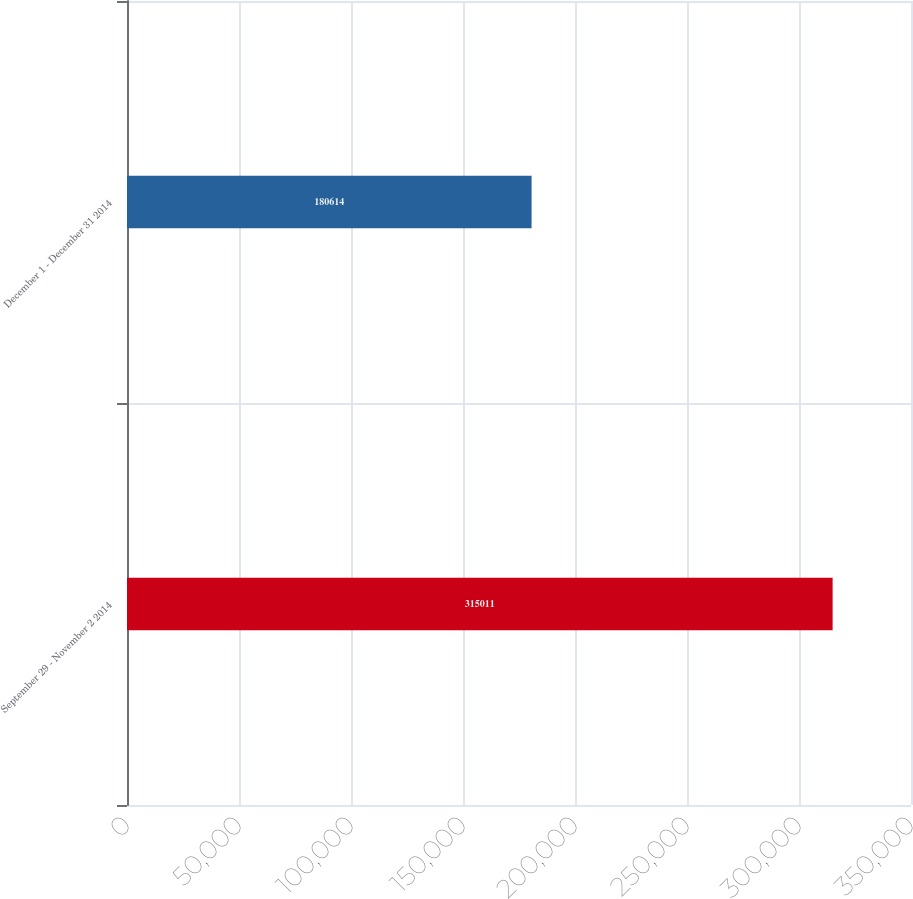<chart> <loc_0><loc_0><loc_500><loc_500><bar_chart><fcel>September 29 - November 2 2014<fcel>December 1 - December 31 2014<nl><fcel>315011<fcel>180614<nl></chart> 